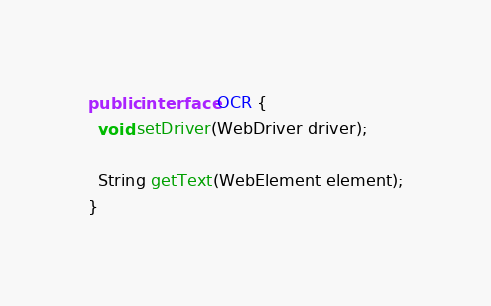<code> <loc_0><loc_0><loc_500><loc_500><_Java_>
public interface OCR {
  void setDriver(WebDriver driver);

  String getText(WebElement element);
}
</code> 